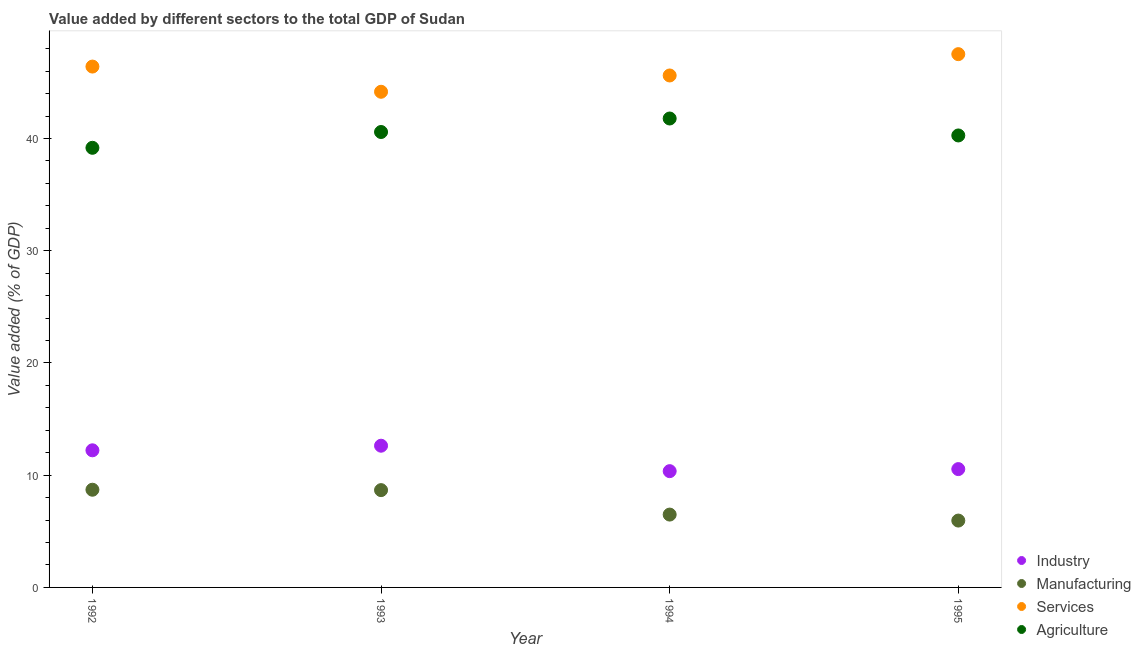Is the number of dotlines equal to the number of legend labels?
Offer a very short reply. Yes. What is the value added by agricultural sector in 1993?
Provide a succinct answer. 40.58. Across all years, what is the maximum value added by industrial sector?
Provide a succinct answer. 12.63. Across all years, what is the minimum value added by agricultural sector?
Offer a very short reply. 39.17. What is the total value added by manufacturing sector in the graph?
Provide a short and direct response. 29.82. What is the difference between the value added by agricultural sector in 1992 and that in 1995?
Your answer should be very brief. -1.1. What is the difference between the value added by agricultural sector in 1994 and the value added by services sector in 1992?
Provide a short and direct response. -4.63. What is the average value added by services sector per year?
Make the answer very short. 45.92. In the year 1994, what is the difference between the value added by agricultural sector and value added by manufacturing sector?
Your answer should be compact. 35.29. In how many years, is the value added by industrial sector greater than 26 %?
Keep it short and to the point. 0. What is the ratio of the value added by services sector in 1993 to that in 1994?
Give a very brief answer. 0.97. What is the difference between the highest and the second highest value added by manufacturing sector?
Make the answer very short. 0.04. What is the difference between the highest and the lowest value added by manufacturing sector?
Keep it short and to the point. 2.75. Is the sum of the value added by industrial sector in 1994 and 1995 greater than the maximum value added by services sector across all years?
Keep it short and to the point. No. Is it the case that in every year, the sum of the value added by manufacturing sector and value added by agricultural sector is greater than the sum of value added by industrial sector and value added by services sector?
Ensure brevity in your answer.  No. Is it the case that in every year, the sum of the value added by industrial sector and value added by manufacturing sector is greater than the value added by services sector?
Provide a short and direct response. No. How many years are there in the graph?
Your answer should be compact. 4. What is the difference between two consecutive major ticks on the Y-axis?
Make the answer very short. 10. Are the values on the major ticks of Y-axis written in scientific E-notation?
Ensure brevity in your answer.  No. Does the graph contain grids?
Give a very brief answer. No. Where does the legend appear in the graph?
Offer a terse response. Bottom right. How are the legend labels stacked?
Ensure brevity in your answer.  Vertical. What is the title of the graph?
Your answer should be compact. Value added by different sectors to the total GDP of Sudan. Does "First 20% of population" appear as one of the legend labels in the graph?
Give a very brief answer. No. What is the label or title of the Y-axis?
Keep it short and to the point. Value added (% of GDP). What is the Value added (% of GDP) in Industry in 1992?
Keep it short and to the point. 12.22. What is the Value added (% of GDP) of Manufacturing in 1992?
Your answer should be compact. 8.7. What is the Value added (% of GDP) in Services in 1992?
Keep it short and to the point. 46.41. What is the Value added (% of GDP) in Agriculture in 1992?
Ensure brevity in your answer.  39.17. What is the Value added (% of GDP) in Industry in 1993?
Provide a short and direct response. 12.63. What is the Value added (% of GDP) in Manufacturing in 1993?
Make the answer very short. 8.67. What is the Value added (% of GDP) in Services in 1993?
Make the answer very short. 44.16. What is the Value added (% of GDP) in Agriculture in 1993?
Give a very brief answer. 40.58. What is the Value added (% of GDP) in Industry in 1994?
Keep it short and to the point. 10.36. What is the Value added (% of GDP) in Manufacturing in 1994?
Your answer should be compact. 6.49. What is the Value added (% of GDP) in Services in 1994?
Your answer should be very brief. 45.61. What is the Value added (% of GDP) of Agriculture in 1994?
Provide a succinct answer. 41.78. What is the Value added (% of GDP) of Industry in 1995?
Ensure brevity in your answer.  10.54. What is the Value added (% of GDP) in Manufacturing in 1995?
Offer a very short reply. 5.96. What is the Value added (% of GDP) in Services in 1995?
Provide a short and direct response. 47.51. What is the Value added (% of GDP) in Agriculture in 1995?
Provide a short and direct response. 40.27. Across all years, what is the maximum Value added (% of GDP) in Industry?
Your answer should be compact. 12.63. Across all years, what is the maximum Value added (% of GDP) of Manufacturing?
Provide a short and direct response. 8.7. Across all years, what is the maximum Value added (% of GDP) of Services?
Provide a short and direct response. 47.51. Across all years, what is the maximum Value added (% of GDP) of Agriculture?
Provide a succinct answer. 41.78. Across all years, what is the minimum Value added (% of GDP) in Industry?
Provide a short and direct response. 10.36. Across all years, what is the minimum Value added (% of GDP) in Manufacturing?
Offer a very short reply. 5.96. Across all years, what is the minimum Value added (% of GDP) in Services?
Give a very brief answer. 44.16. Across all years, what is the minimum Value added (% of GDP) of Agriculture?
Ensure brevity in your answer.  39.17. What is the total Value added (% of GDP) of Industry in the graph?
Your answer should be very brief. 45.75. What is the total Value added (% of GDP) in Manufacturing in the graph?
Your answer should be compact. 29.82. What is the total Value added (% of GDP) in Services in the graph?
Your response must be concise. 183.7. What is the total Value added (% of GDP) in Agriculture in the graph?
Ensure brevity in your answer.  161.8. What is the difference between the Value added (% of GDP) in Industry in 1992 and that in 1993?
Give a very brief answer. -0.41. What is the difference between the Value added (% of GDP) of Manufacturing in 1992 and that in 1993?
Offer a terse response. 0.04. What is the difference between the Value added (% of GDP) of Services in 1992 and that in 1993?
Offer a very short reply. 2.24. What is the difference between the Value added (% of GDP) of Agriculture in 1992 and that in 1993?
Ensure brevity in your answer.  -1.41. What is the difference between the Value added (% of GDP) in Industry in 1992 and that in 1994?
Provide a succinct answer. 1.86. What is the difference between the Value added (% of GDP) of Manufacturing in 1992 and that in 1994?
Offer a terse response. 2.21. What is the difference between the Value added (% of GDP) in Services in 1992 and that in 1994?
Your response must be concise. 0.79. What is the difference between the Value added (% of GDP) in Agriculture in 1992 and that in 1994?
Keep it short and to the point. -2.61. What is the difference between the Value added (% of GDP) in Industry in 1992 and that in 1995?
Offer a very short reply. 1.67. What is the difference between the Value added (% of GDP) in Manufacturing in 1992 and that in 1995?
Provide a short and direct response. 2.75. What is the difference between the Value added (% of GDP) of Services in 1992 and that in 1995?
Ensure brevity in your answer.  -1.11. What is the difference between the Value added (% of GDP) in Agriculture in 1992 and that in 1995?
Give a very brief answer. -1.1. What is the difference between the Value added (% of GDP) in Industry in 1993 and that in 1994?
Give a very brief answer. 2.27. What is the difference between the Value added (% of GDP) in Manufacturing in 1993 and that in 1994?
Provide a succinct answer. 2.18. What is the difference between the Value added (% of GDP) of Services in 1993 and that in 1994?
Your response must be concise. -1.45. What is the difference between the Value added (% of GDP) in Agriculture in 1993 and that in 1994?
Ensure brevity in your answer.  -1.2. What is the difference between the Value added (% of GDP) of Industry in 1993 and that in 1995?
Offer a very short reply. 2.08. What is the difference between the Value added (% of GDP) of Manufacturing in 1993 and that in 1995?
Offer a very short reply. 2.71. What is the difference between the Value added (% of GDP) in Services in 1993 and that in 1995?
Your answer should be compact. -3.35. What is the difference between the Value added (% of GDP) in Agriculture in 1993 and that in 1995?
Ensure brevity in your answer.  0.31. What is the difference between the Value added (% of GDP) in Industry in 1994 and that in 1995?
Your answer should be very brief. -0.18. What is the difference between the Value added (% of GDP) of Manufacturing in 1994 and that in 1995?
Give a very brief answer. 0.53. What is the difference between the Value added (% of GDP) of Services in 1994 and that in 1995?
Offer a very short reply. -1.9. What is the difference between the Value added (% of GDP) of Agriculture in 1994 and that in 1995?
Give a very brief answer. 1.51. What is the difference between the Value added (% of GDP) in Industry in 1992 and the Value added (% of GDP) in Manufacturing in 1993?
Ensure brevity in your answer.  3.55. What is the difference between the Value added (% of GDP) in Industry in 1992 and the Value added (% of GDP) in Services in 1993?
Your response must be concise. -31.94. What is the difference between the Value added (% of GDP) of Industry in 1992 and the Value added (% of GDP) of Agriculture in 1993?
Ensure brevity in your answer.  -28.36. What is the difference between the Value added (% of GDP) of Manufacturing in 1992 and the Value added (% of GDP) of Services in 1993?
Your response must be concise. -35.46. What is the difference between the Value added (% of GDP) of Manufacturing in 1992 and the Value added (% of GDP) of Agriculture in 1993?
Ensure brevity in your answer.  -31.87. What is the difference between the Value added (% of GDP) in Services in 1992 and the Value added (% of GDP) in Agriculture in 1993?
Give a very brief answer. 5.83. What is the difference between the Value added (% of GDP) in Industry in 1992 and the Value added (% of GDP) in Manufacturing in 1994?
Your response must be concise. 5.73. What is the difference between the Value added (% of GDP) of Industry in 1992 and the Value added (% of GDP) of Services in 1994?
Offer a terse response. -33.4. What is the difference between the Value added (% of GDP) of Industry in 1992 and the Value added (% of GDP) of Agriculture in 1994?
Ensure brevity in your answer.  -29.56. What is the difference between the Value added (% of GDP) of Manufacturing in 1992 and the Value added (% of GDP) of Services in 1994?
Offer a terse response. -36.91. What is the difference between the Value added (% of GDP) in Manufacturing in 1992 and the Value added (% of GDP) in Agriculture in 1994?
Offer a terse response. -33.08. What is the difference between the Value added (% of GDP) of Services in 1992 and the Value added (% of GDP) of Agriculture in 1994?
Provide a succinct answer. 4.63. What is the difference between the Value added (% of GDP) in Industry in 1992 and the Value added (% of GDP) in Manufacturing in 1995?
Your response must be concise. 6.26. What is the difference between the Value added (% of GDP) in Industry in 1992 and the Value added (% of GDP) in Services in 1995?
Provide a succinct answer. -35.3. What is the difference between the Value added (% of GDP) of Industry in 1992 and the Value added (% of GDP) of Agriculture in 1995?
Make the answer very short. -28.05. What is the difference between the Value added (% of GDP) in Manufacturing in 1992 and the Value added (% of GDP) in Services in 1995?
Offer a terse response. -38.81. What is the difference between the Value added (% of GDP) in Manufacturing in 1992 and the Value added (% of GDP) in Agriculture in 1995?
Make the answer very short. -31.57. What is the difference between the Value added (% of GDP) in Services in 1992 and the Value added (% of GDP) in Agriculture in 1995?
Your answer should be very brief. 6.14. What is the difference between the Value added (% of GDP) in Industry in 1993 and the Value added (% of GDP) in Manufacturing in 1994?
Offer a terse response. 6.14. What is the difference between the Value added (% of GDP) of Industry in 1993 and the Value added (% of GDP) of Services in 1994?
Offer a very short reply. -32.99. What is the difference between the Value added (% of GDP) in Industry in 1993 and the Value added (% of GDP) in Agriculture in 1994?
Give a very brief answer. -29.15. What is the difference between the Value added (% of GDP) in Manufacturing in 1993 and the Value added (% of GDP) in Services in 1994?
Provide a short and direct response. -36.94. What is the difference between the Value added (% of GDP) of Manufacturing in 1993 and the Value added (% of GDP) of Agriculture in 1994?
Your answer should be compact. -33.11. What is the difference between the Value added (% of GDP) in Services in 1993 and the Value added (% of GDP) in Agriculture in 1994?
Provide a short and direct response. 2.38. What is the difference between the Value added (% of GDP) of Industry in 1993 and the Value added (% of GDP) of Manufacturing in 1995?
Make the answer very short. 6.67. What is the difference between the Value added (% of GDP) of Industry in 1993 and the Value added (% of GDP) of Services in 1995?
Your response must be concise. -34.89. What is the difference between the Value added (% of GDP) of Industry in 1993 and the Value added (% of GDP) of Agriculture in 1995?
Ensure brevity in your answer.  -27.64. What is the difference between the Value added (% of GDP) in Manufacturing in 1993 and the Value added (% of GDP) in Services in 1995?
Provide a short and direct response. -38.84. What is the difference between the Value added (% of GDP) of Manufacturing in 1993 and the Value added (% of GDP) of Agriculture in 1995?
Offer a terse response. -31.6. What is the difference between the Value added (% of GDP) in Services in 1993 and the Value added (% of GDP) in Agriculture in 1995?
Provide a succinct answer. 3.89. What is the difference between the Value added (% of GDP) of Industry in 1994 and the Value added (% of GDP) of Manufacturing in 1995?
Provide a succinct answer. 4.4. What is the difference between the Value added (% of GDP) in Industry in 1994 and the Value added (% of GDP) in Services in 1995?
Give a very brief answer. -37.15. What is the difference between the Value added (% of GDP) in Industry in 1994 and the Value added (% of GDP) in Agriculture in 1995?
Provide a succinct answer. -29.91. What is the difference between the Value added (% of GDP) of Manufacturing in 1994 and the Value added (% of GDP) of Services in 1995?
Your response must be concise. -41.02. What is the difference between the Value added (% of GDP) of Manufacturing in 1994 and the Value added (% of GDP) of Agriculture in 1995?
Give a very brief answer. -33.78. What is the difference between the Value added (% of GDP) of Services in 1994 and the Value added (% of GDP) of Agriculture in 1995?
Provide a short and direct response. 5.34. What is the average Value added (% of GDP) in Industry per year?
Give a very brief answer. 11.44. What is the average Value added (% of GDP) in Manufacturing per year?
Offer a very short reply. 7.46. What is the average Value added (% of GDP) in Services per year?
Offer a very short reply. 45.92. What is the average Value added (% of GDP) in Agriculture per year?
Give a very brief answer. 40.45. In the year 1992, what is the difference between the Value added (% of GDP) of Industry and Value added (% of GDP) of Manufacturing?
Your answer should be compact. 3.51. In the year 1992, what is the difference between the Value added (% of GDP) in Industry and Value added (% of GDP) in Services?
Give a very brief answer. -34.19. In the year 1992, what is the difference between the Value added (% of GDP) of Industry and Value added (% of GDP) of Agriculture?
Your answer should be compact. -26.95. In the year 1992, what is the difference between the Value added (% of GDP) of Manufacturing and Value added (% of GDP) of Services?
Your response must be concise. -37.7. In the year 1992, what is the difference between the Value added (% of GDP) of Manufacturing and Value added (% of GDP) of Agriculture?
Provide a succinct answer. -30.47. In the year 1992, what is the difference between the Value added (% of GDP) in Services and Value added (% of GDP) in Agriculture?
Ensure brevity in your answer.  7.24. In the year 1993, what is the difference between the Value added (% of GDP) in Industry and Value added (% of GDP) in Manufacturing?
Provide a short and direct response. 3.96. In the year 1993, what is the difference between the Value added (% of GDP) in Industry and Value added (% of GDP) in Services?
Your answer should be very brief. -31.54. In the year 1993, what is the difference between the Value added (% of GDP) in Industry and Value added (% of GDP) in Agriculture?
Make the answer very short. -27.95. In the year 1993, what is the difference between the Value added (% of GDP) of Manufacturing and Value added (% of GDP) of Services?
Ensure brevity in your answer.  -35.49. In the year 1993, what is the difference between the Value added (% of GDP) of Manufacturing and Value added (% of GDP) of Agriculture?
Give a very brief answer. -31.91. In the year 1993, what is the difference between the Value added (% of GDP) of Services and Value added (% of GDP) of Agriculture?
Offer a very short reply. 3.58. In the year 1994, what is the difference between the Value added (% of GDP) in Industry and Value added (% of GDP) in Manufacturing?
Keep it short and to the point. 3.87. In the year 1994, what is the difference between the Value added (% of GDP) of Industry and Value added (% of GDP) of Services?
Provide a short and direct response. -35.25. In the year 1994, what is the difference between the Value added (% of GDP) of Industry and Value added (% of GDP) of Agriculture?
Ensure brevity in your answer.  -31.42. In the year 1994, what is the difference between the Value added (% of GDP) of Manufacturing and Value added (% of GDP) of Services?
Provide a succinct answer. -39.12. In the year 1994, what is the difference between the Value added (% of GDP) in Manufacturing and Value added (% of GDP) in Agriculture?
Your answer should be very brief. -35.29. In the year 1994, what is the difference between the Value added (% of GDP) in Services and Value added (% of GDP) in Agriculture?
Provide a short and direct response. 3.83. In the year 1995, what is the difference between the Value added (% of GDP) of Industry and Value added (% of GDP) of Manufacturing?
Provide a short and direct response. 4.59. In the year 1995, what is the difference between the Value added (% of GDP) of Industry and Value added (% of GDP) of Services?
Give a very brief answer. -36.97. In the year 1995, what is the difference between the Value added (% of GDP) in Industry and Value added (% of GDP) in Agriculture?
Provide a succinct answer. -29.73. In the year 1995, what is the difference between the Value added (% of GDP) in Manufacturing and Value added (% of GDP) in Services?
Ensure brevity in your answer.  -41.56. In the year 1995, what is the difference between the Value added (% of GDP) of Manufacturing and Value added (% of GDP) of Agriculture?
Make the answer very short. -34.31. In the year 1995, what is the difference between the Value added (% of GDP) of Services and Value added (% of GDP) of Agriculture?
Your response must be concise. 7.24. What is the ratio of the Value added (% of GDP) of Industry in 1992 to that in 1993?
Your response must be concise. 0.97. What is the ratio of the Value added (% of GDP) in Manufacturing in 1992 to that in 1993?
Offer a very short reply. 1. What is the ratio of the Value added (% of GDP) of Services in 1992 to that in 1993?
Provide a short and direct response. 1.05. What is the ratio of the Value added (% of GDP) in Agriculture in 1992 to that in 1993?
Your answer should be very brief. 0.97. What is the ratio of the Value added (% of GDP) in Industry in 1992 to that in 1994?
Give a very brief answer. 1.18. What is the ratio of the Value added (% of GDP) of Manufacturing in 1992 to that in 1994?
Provide a succinct answer. 1.34. What is the ratio of the Value added (% of GDP) of Services in 1992 to that in 1994?
Provide a short and direct response. 1.02. What is the ratio of the Value added (% of GDP) in Industry in 1992 to that in 1995?
Ensure brevity in your answer.  1.16. What is the ratio of the Value added (% of GDP) in Manufacturing in 1992 to that in 1995?
Offer a very short reply. 1.46. What is the ratio of the Value added (% of GDP) of Services in 1992 to that in 1995?
Offer a terse response. 0.98. What is the ratio of the Value added (% of GDP) in Agriculture in 1992 to that in 1995?
Offer a very short reply. 0.97. What is the ratio of the Value added (% of GDP) of Industry in 1993 to that in 1994?
Offer a terse response. 1.22. What is the ratio of the Value added (% of GDP) in Manufacturing in 1993 to that in 1994?
Give a very brief answer. 1.34. What is the ratio of the Value added (% of GDP) of Services in 1993 to that in 1994?
Make the answer very short. 0.97. What is the ratio of the Value added (% of GDP) in Agriculture in 1993 to that in 1994?
Your answer should be very brief. 0.97. What is the ratio of the Value added (% of GDP) of Industry in 1993 to that in 1995?
Provide a succinct answer. 1.2. What is the ratio of the Value added (% of GDP) in Manufacturing in 1993 to that in 1995?
Make the answer very short. 1.46. What is the ratio of the Value added (% of GDP) in Services in 1993 to that in 1995?
Offer a terse response. 0.93. What is the ratio of the Value added (% of GDP) in Agriculture in 1993 to that in 1995?
Keep it short and to the point. 1.01. What is the ratio of the Value added (% of GDP) of Industry in 1994 to that in 1995?
Give a very brief answer. 0.98. What is the ratio of the Value added (% of GDP) of Manufacturing in 1994 to that in 1995?
Offer a terse response. 1.09. What is the ratio of the Value added (% of GDP) of Agriculture in 1994 to that in 1995?
Your answer should be compact. 1.04. What is the difference between the highest and the second highest Value added (% of GDP) in Industry?
Your response must be concise. 0.41. What is the difference between the highest and the second highest Value added (% of GDP) in Manufacturing?
Your answer should be very brief. 0.04. What is the difference between the highest and the second highest Value added (% of GDP) of Services?
Keep it short and to the point. 1.11. What is the difference between the highest and the second highest Value added (% of GDP) in Agriculture?
Ensure brevity in your answer.  1.2. What is the difference between the highest and the lowest Value added (% of GDP) of Industry?
Provide a short and direct response. 2.27. What is the difference between the highest and the lowest Value added (% of GDP) in Manufacturing?
Provide a short and direct response. 2.75. What is the difference between the highest and the lowest Value added (% of GDP) in Services?
Offer a terse response. 3.35. What is the difference between the highest and the lowest Value added (% of GDP) in Agriculture?
Offer a terse response. 2.61. 